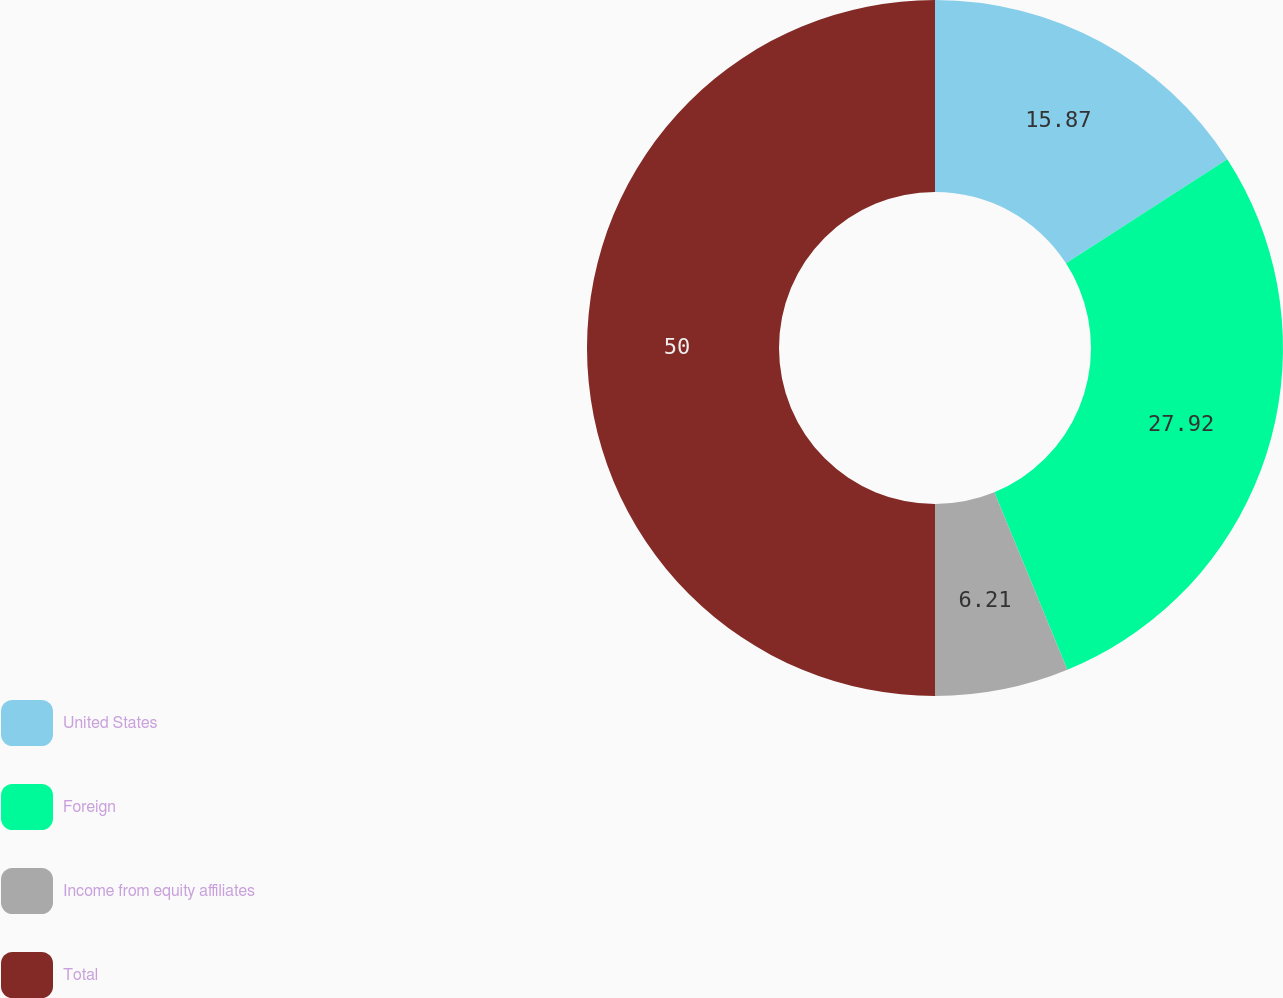Convert chart. <chart><loc_0><loc_0><loc_500><loc_500><pie_chart><fcel>United States<fcel>Foreign<fcel>Income from equity affiliates<fcel>Total<nl><fcel>15.87%<fcel>27.92%<fcel>6.21%<fcel>50.0%<nl></chart> 